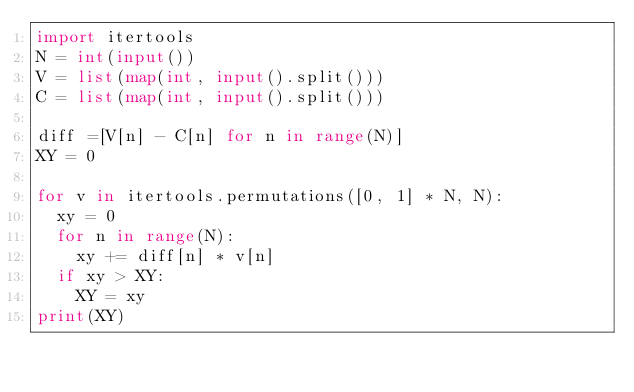Convert code to text. <code><loc_0><loc_0><loc_500><loc_500><_Python_>import itertools
N = int(input())
V = list(map(int, input().split()))
C = list(map(int, input().split()))

diff =[V[n] - C[n] for n in range(N)]
XY = 0

for v in itertools.permutations([0, 1] * N, N):
  xy = 0
  for n in range(N):
    xy += diff[n] * v[n]
  if xy > XY:
    XY = xy
print(XY)</code> 